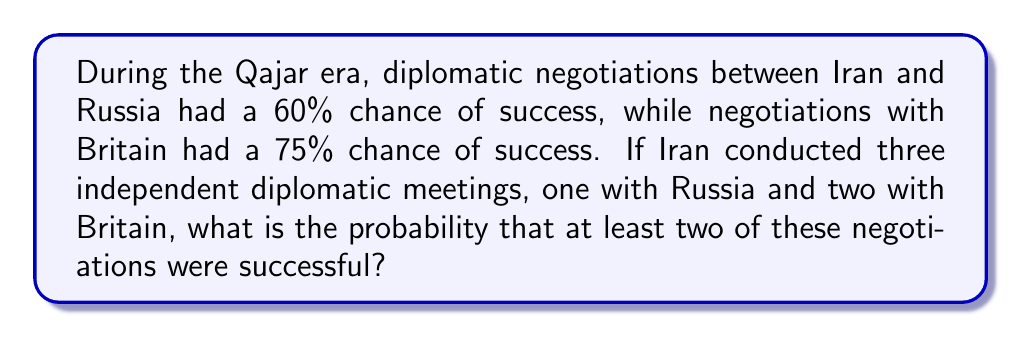Can you answer this question? Let's approach this step-by-step using probability theory:

1) First, let's define our events:
   R: Successful negotiation with Russia (P(R) = 0.60)
   B: Successful negotiation with Britain (P(B) = 0.75)

2) We need to find the probability of at least two successful negotiations out of three. This can happen in three ways:
   a) All three negotiations are successful
   b) The Russian negotiation and one British negotiation are successful
   c) Both British negotiations are successful, but the Russian one fails

3) Let's calculate each of these probabilities:

   a) P(All successful) = P(R) * P(B) * P(B)
      $$ P(All) = 0.60 * 0.75 * 0.75 = 0.3375 $$

   b) P(Russia and one Britain) = P(R) * P(B) * (1 - P(B)) * 2
      (We multiply by 2 because the successful British negotiation could be either the first or the second)
      $$ P(R\text{ and one B}) = 0.60 * 0.75 * 0.25 * 2 = 0.225 $$

   c) P(Both Britain, not Russia) = (1 - P(R)) * P(B) * P(B)
      $$ P(\text{Both B, not R}) = 0.40 * 0.75 * 0.75 = 0.225 $$

4) The total probability is the sum of these three probabilities:
   $$ P(\text{at least two successful}) = 0.3375 + 0.225 + 0.225 = 0.7875 $$

Therefore, the probability of at least two successful negotiations is 0.7875 or 78.75%.
Answer: 0.7875 or 78.75% 